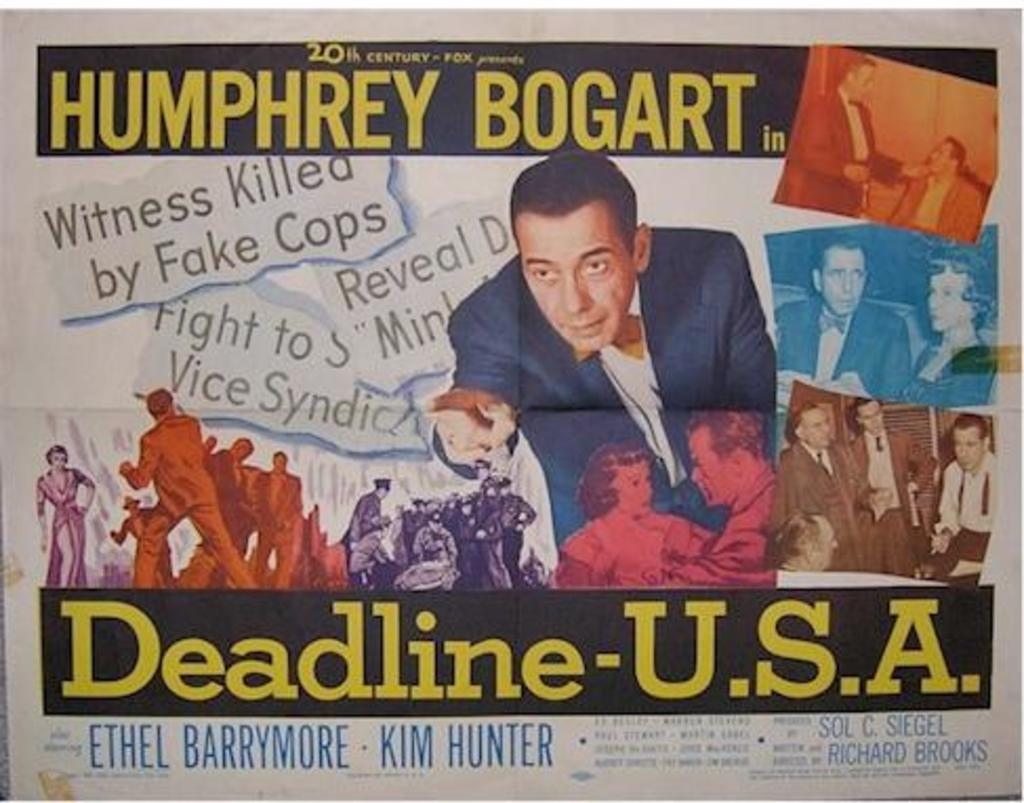<image>
Relay a brief, clear account of the picture shown. a news paper clipping with humphrey bogart in deadline usa. 